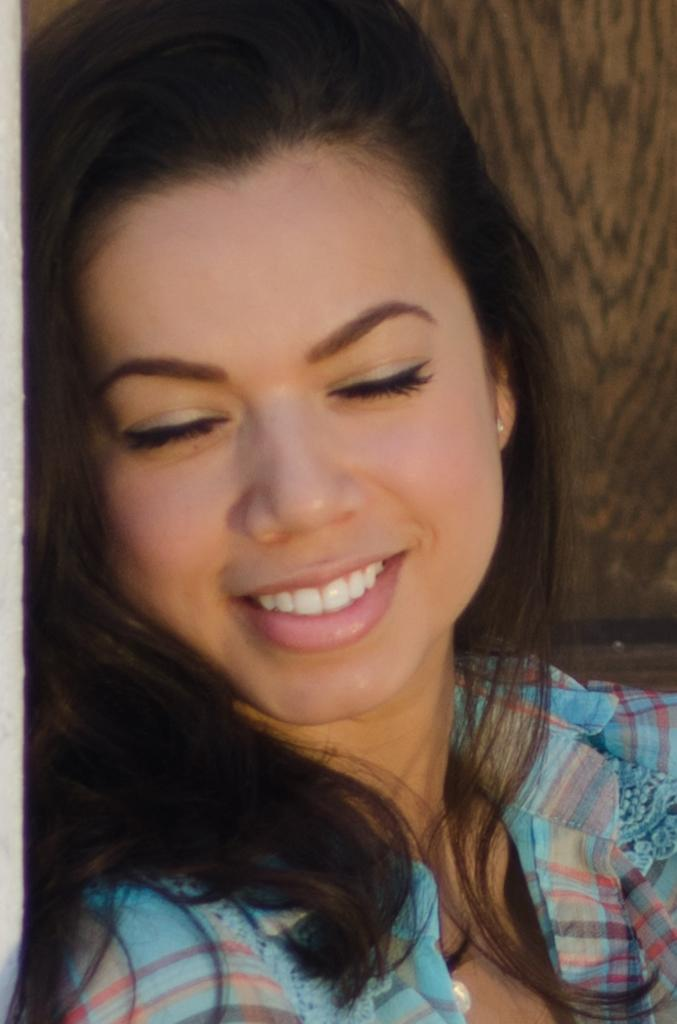Who is the main subject in the image? There is a lady in the center of the image. What is the lady doing in the image? The lady is smiling. What is the lady wearing in the image? The lady is wearing a shirt. What can be seen in the background of the image? There is a wall visible in the background of the image. Where is the playground located in the image? There is no playground present in the image. What type of form does the lady need to fill out in the image? There is no form present in the image, and no indication that the lady needs to fill one out. 